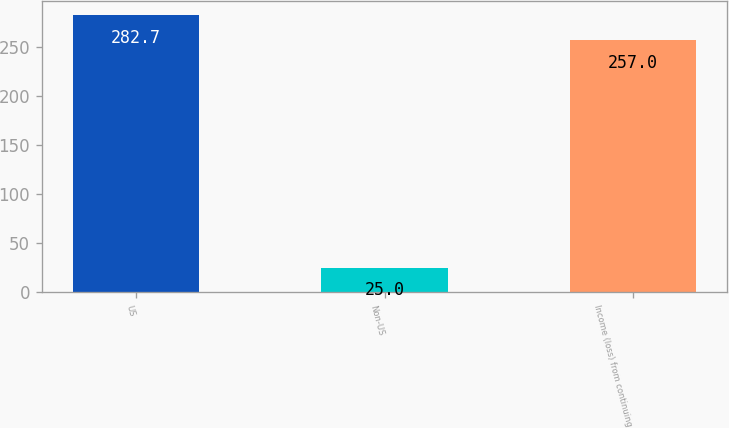<chart> <loc_0><loc_0><loc_500><loc_500><bar_chart><fcel>US<fcel>Non-US<fcel>Income (loss) from continuing<nl><fcel>282.7<fcel>25<fcel>257<nl></chart> 